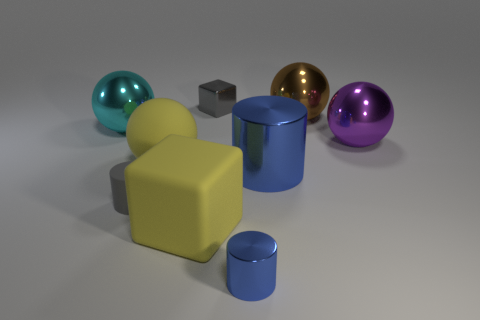What number of big objects are blue metal things or yellow matte spheres? In the image, there are 2 large objects fitting the description; one is a blue metallic cylinder and the other is a yellow matte sphere. 